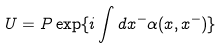<formula> <loc_0><loc_0><loc_500><loc_500>U = P \exp \{ i \int d x ^ { - } \alpha ( x , x ^ { - } ) \}</formula> 